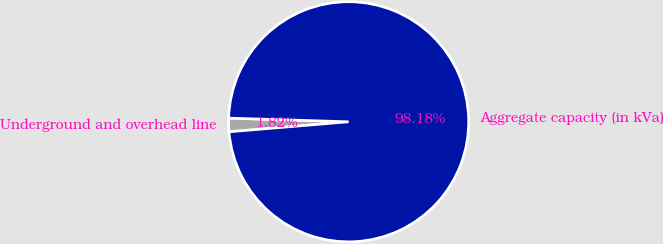Convert chart to OTSL. <chart><loc_0><loc_0><loc_500><loc_500><pie_chart><fcel>Underground and overhead line<fcel>Aggregate capacity (in kVa)<nl><fcel>1.82%<fcel>98.18%<nl></chart> 